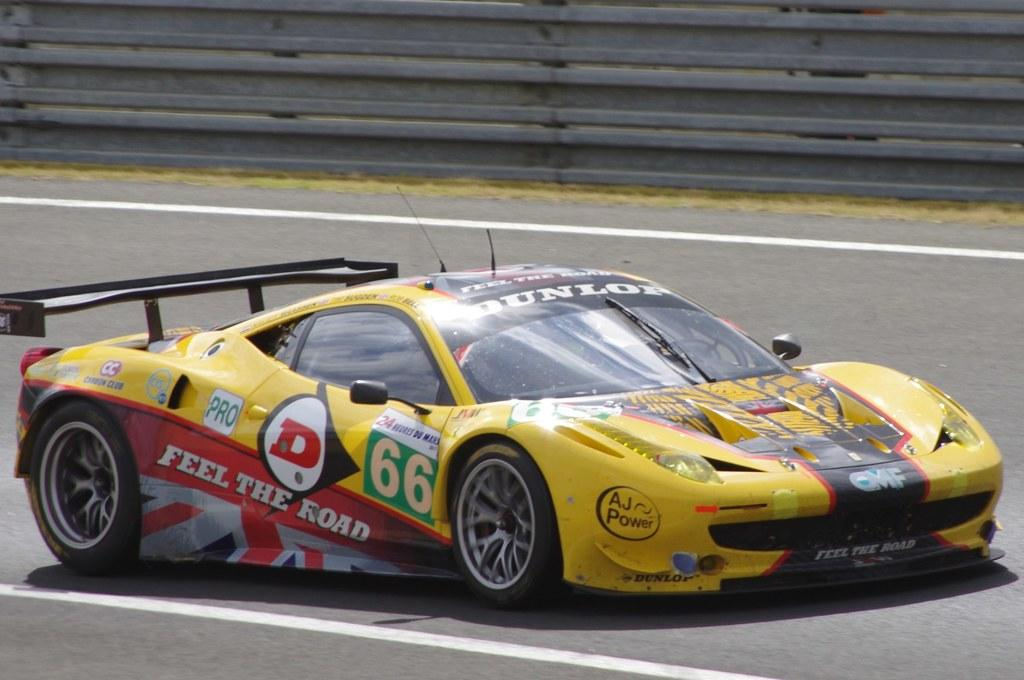What is on the road in the image? There is a vehicle on the road in the image. What can be observed on the vehicle? The vehicle has painted lines on it. What is located near the road in the image? There is a fence visible in the image. Where is the fence situated? The fence is on grassland. What type of soda is being advertised on the fence in the image? There is no soda or advertisement present on the fence in the image; it is simply a fence on grassland. What color is the yarn used to create the title of the image? There is no title or yarn present in the image. 